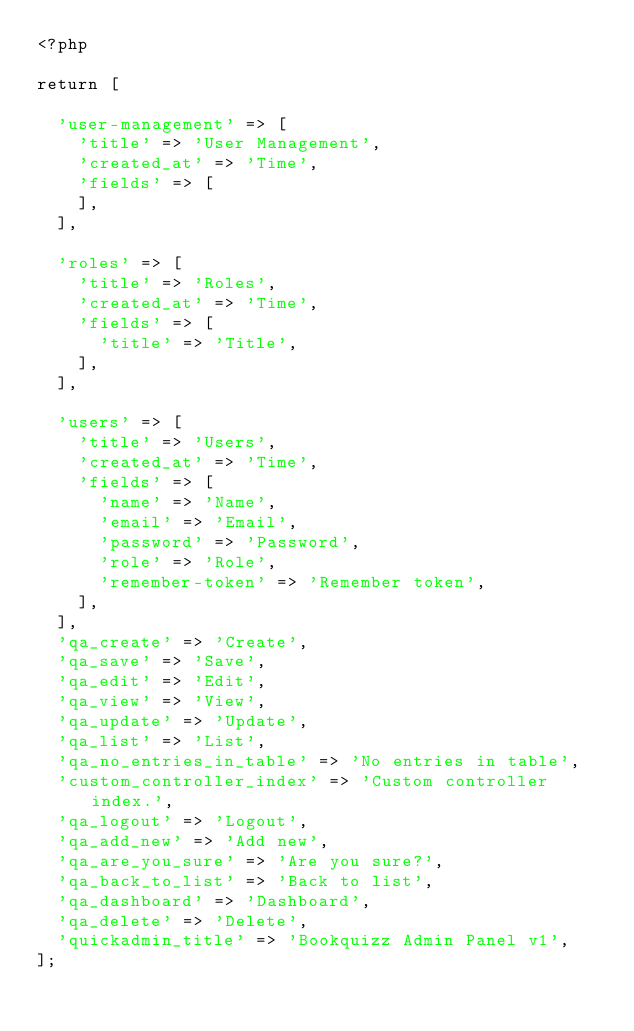<code> <loc_0><loc_0><loc_500><loc_500><_PHP_><?php

return [
		'user-management' => [		'title' => 'User Management',		'created_at' => 'Time',		'fields' => [		],	],
		'roles' => [		'title' => 'Roles',		'created_at' => 'Time',		'fields' => [			'title' => 'Title',		],	],
		'users' => [		'title' => 'Users',		'created_at' => 'Time',		'fields' => [			'name' => 'Name',			'email' => 'Email',			'password' => 'Password',			'role' => 'Role',			'remember-token' => 'Remember token',		],	],
	'qa_create' => 'Create',
	'qa_save' => 'Save',
	'qa_edit' => 'Edit',
	'qa_view' => 'View',
	'qa_update' => 'Update',
	'qa_list' => 'List',
	'qa_no_entries_in_table' => 'No entries in table',
	'custom_controller_index' => 'Custom controller index.',
	'qa_logout' => 'Logout',
	'qa_add_new' => 'Add new',
	'qa_are_you_sure' => 'Are you sure?',
	'qa_back_to_list' => 'Back to list',
	'qa_dashboard' => 'Dashboard',
	'qa_delete' => 'Delete',
	'quickadmin_title' => 'Bookquizz Admin Panel v1',
];</code> 